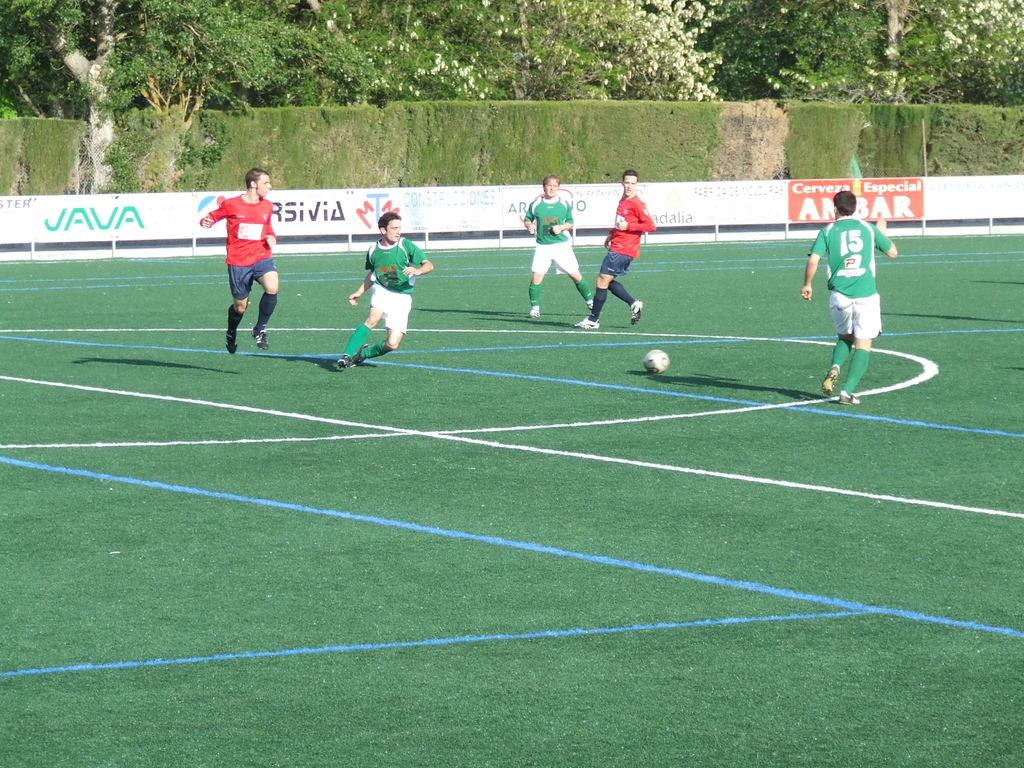Who or what can be seen in the image? There are people in the image. What object is present in the image that people might interact with? There is a ball in the image. What type of surface is visible in the image? There is ground visible in the image. What natural elements can be seen in the image? There are trees in the image. What additional objects with text can be seen in the image? There are boards with text in the image. What type of education can be seen in the image? There is no reference to education in the image; it features people, a ball, ground, trees, and boards with text. 